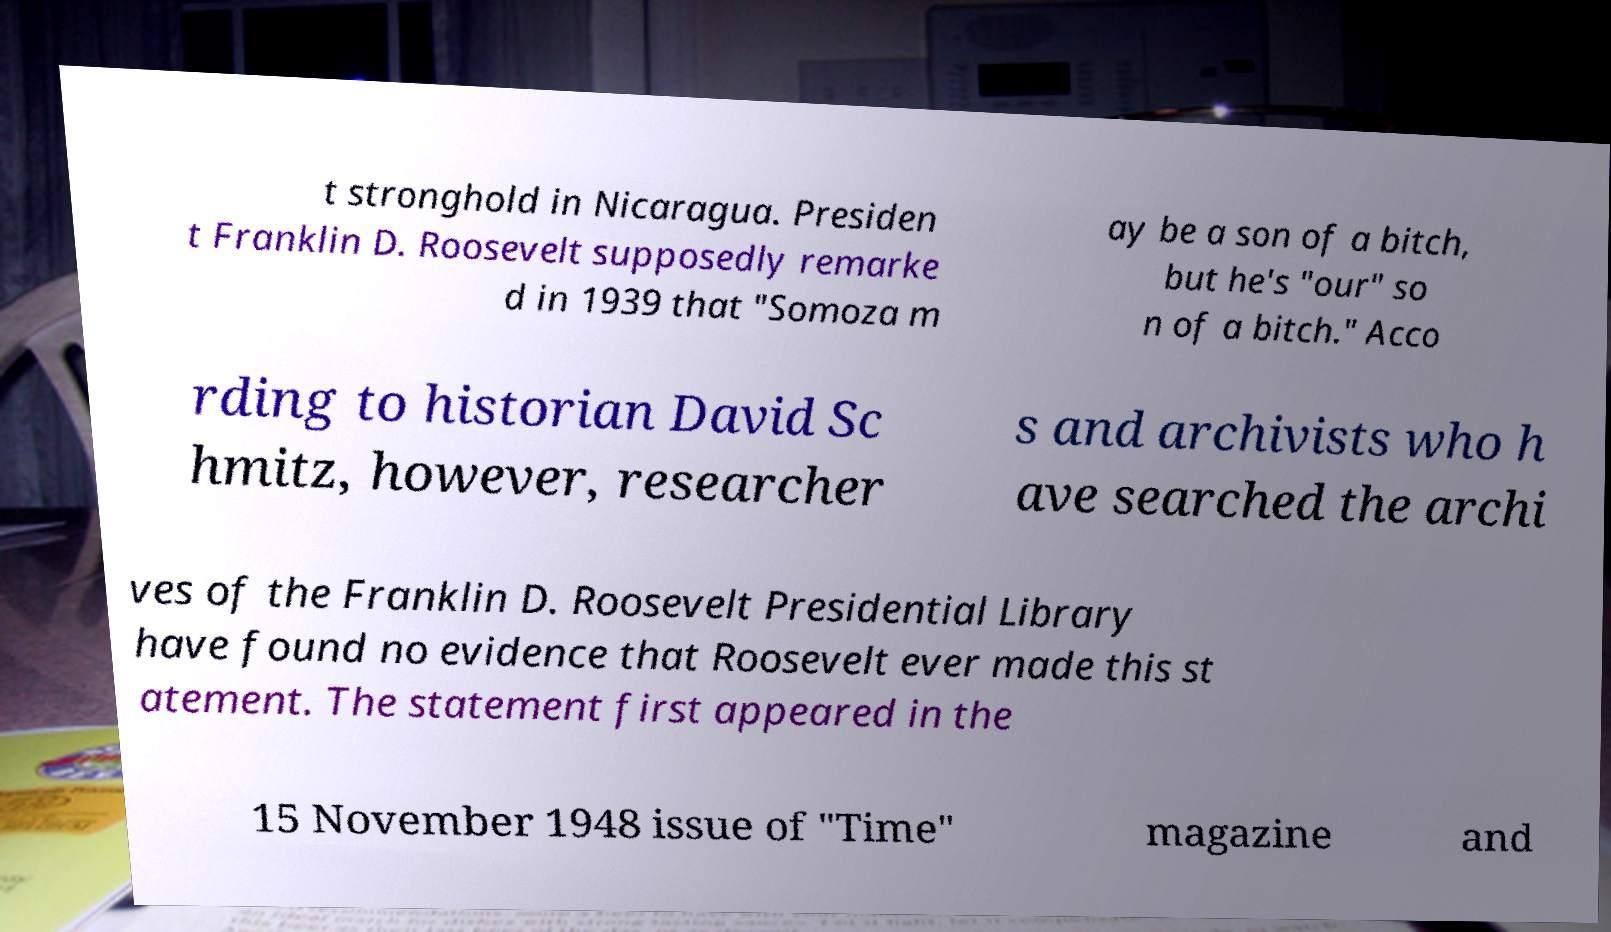There's text embedded in this image that I need extracted. Can you transcribe it verbatim? t stronghold in Nicaragua. Presiden t Franklin D. Roosevelt supposedly remarke d in 1939 that "Somoza m ay be a son of a bitch, but he's "our" so n of a bitch." Acco rding to historian David Sc hmitz, however, researcher s and archivists who h ave searched the archi ves of the Franklin D. Roosevelt Presidential Library have found no evidence that Roosevelt ever made this st atement. The statement first appeared in the 15 November 1948 issue of "Time" magazine and 